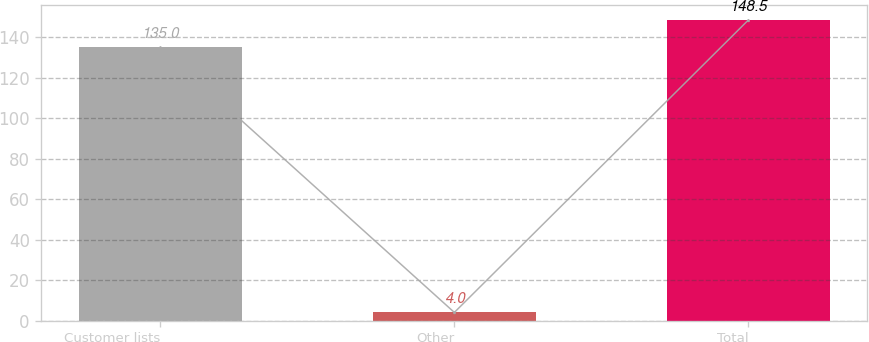<chart> <loc_0><loc_0><loc_500><loc_500><bar_chart><fcel>Customer lists<fcel>Other<fcel>Total<nl><fcel>135<fcel>4<fcel>148.5<nl></chart> 